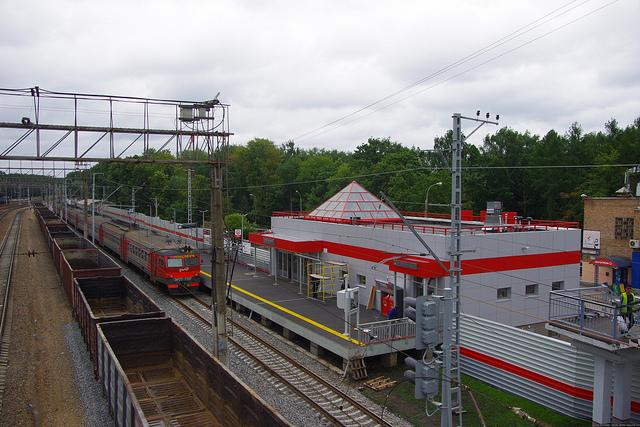These walls have a similar color scheme to what place?

Choices:
A) nathan's
B) arthur treacher's
C) popeye's
D) kfc kfc 